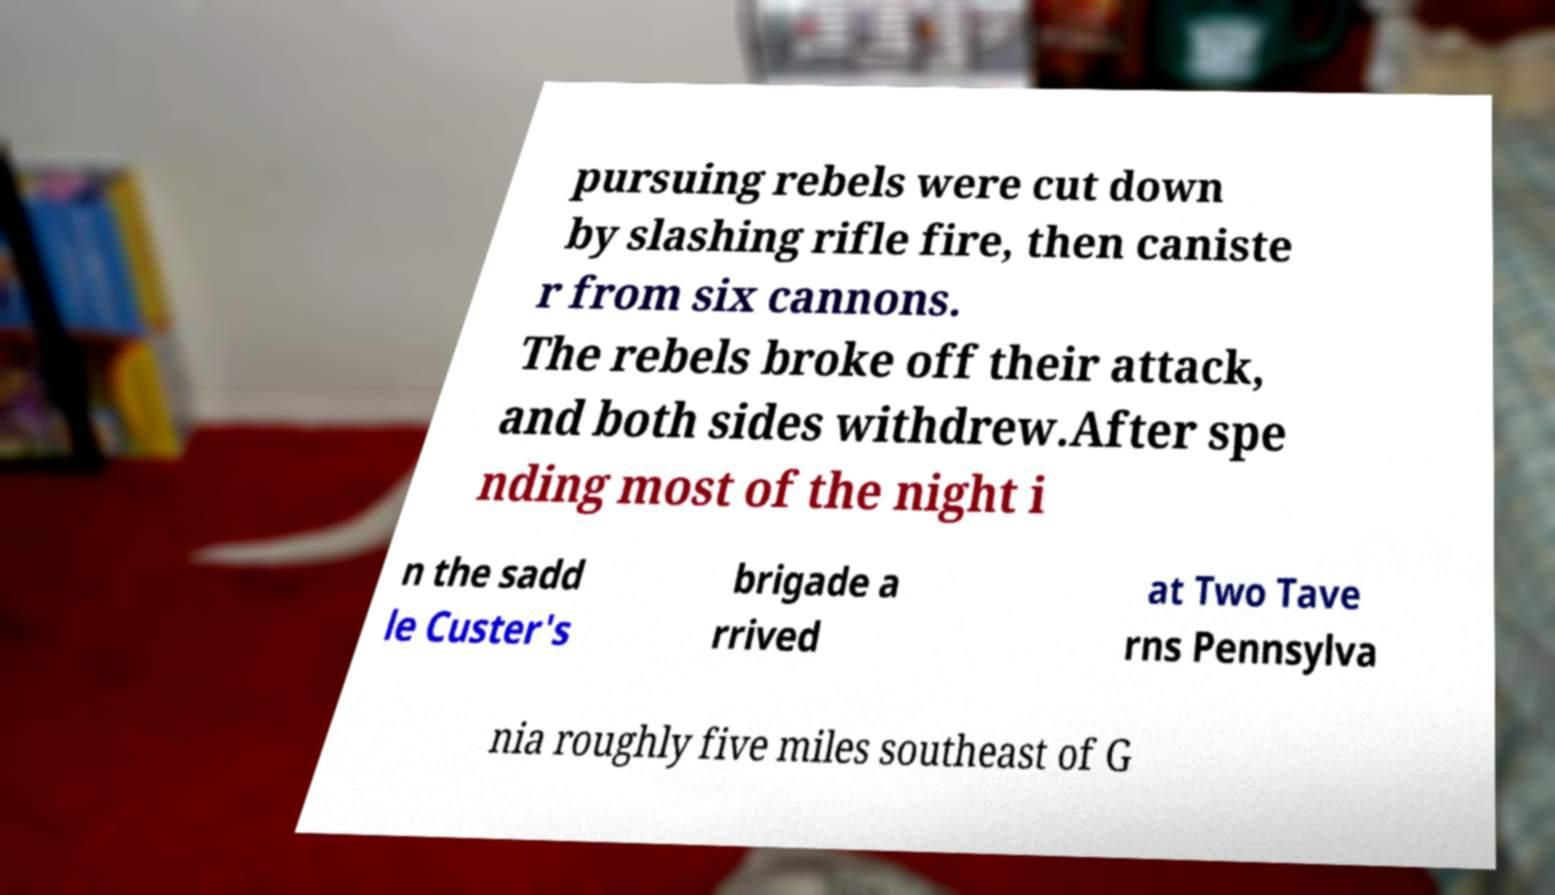Can you read and provide the text displayed in the image?This photo seems to have some interesting text. Can you extract and type it out for me? pursuing rebels were cut down by slashing rifle fire, then caniste r from six cannons. The rebels broke off their attack, and both sides withdrew.After spe nding most of the night i n the sadd le Custer's brigade a rrived at Two Tave rns Pennsylva nia roughly five miles southeast of G 